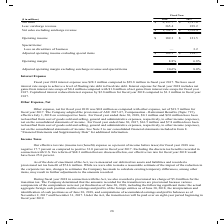According to Carpenter Technology's financial document, What was operating income in 2018? Based on the financial document, the answer is $189.3 million. Also, What was operating income in 2017 as a percentage of net sales? Based on the financial document, the answer is 6.8 percent. Also, In which years was operating income calculated? The document shows two values: 2018 and 2017. From the document: "Fiscal Year ($ in millions) 2018 2017 Net sales $ 2,157.7 $ 1,797.6 Less: surcharge revenue 365.4 239.2 Net sales excluding surcharge rev Fiscal Year ..." Additionally, In which year was the operating margin larger? According to the financial document, 2018. The relevant text states: "Fiscal Year ($ in millions) 2018 2017 Net sales $ 2,157.7 $ 1,797.6 Less: surcharge revenue 365.4 239.2 Net sales excluding surcharg..." Also, can you calculate: What was the change in operating income in 2018 from 2017? Based on the calculation: 189.3-121.5, the result is 67.8 (in millions). This is based on the information: "Operating income $ 189.3 $ 121.5 Operating income $ 189.3 $ 121.5..." The key data points involved are: 121.5, 189.3. Also, can you calculate: What was the percentage change in operating income in 2018 from 2017? To answer this question, I need to perform calculations using the financial data. The calculation is: (189.3-121.5)/121.5, which equals 55.8 (percentage). This is based on the information: "Operating income $ 189.3 $ 121.5 Operating income $ 189.3 $ 121.5..." The key data points involved are: 121.5, 189.3. 